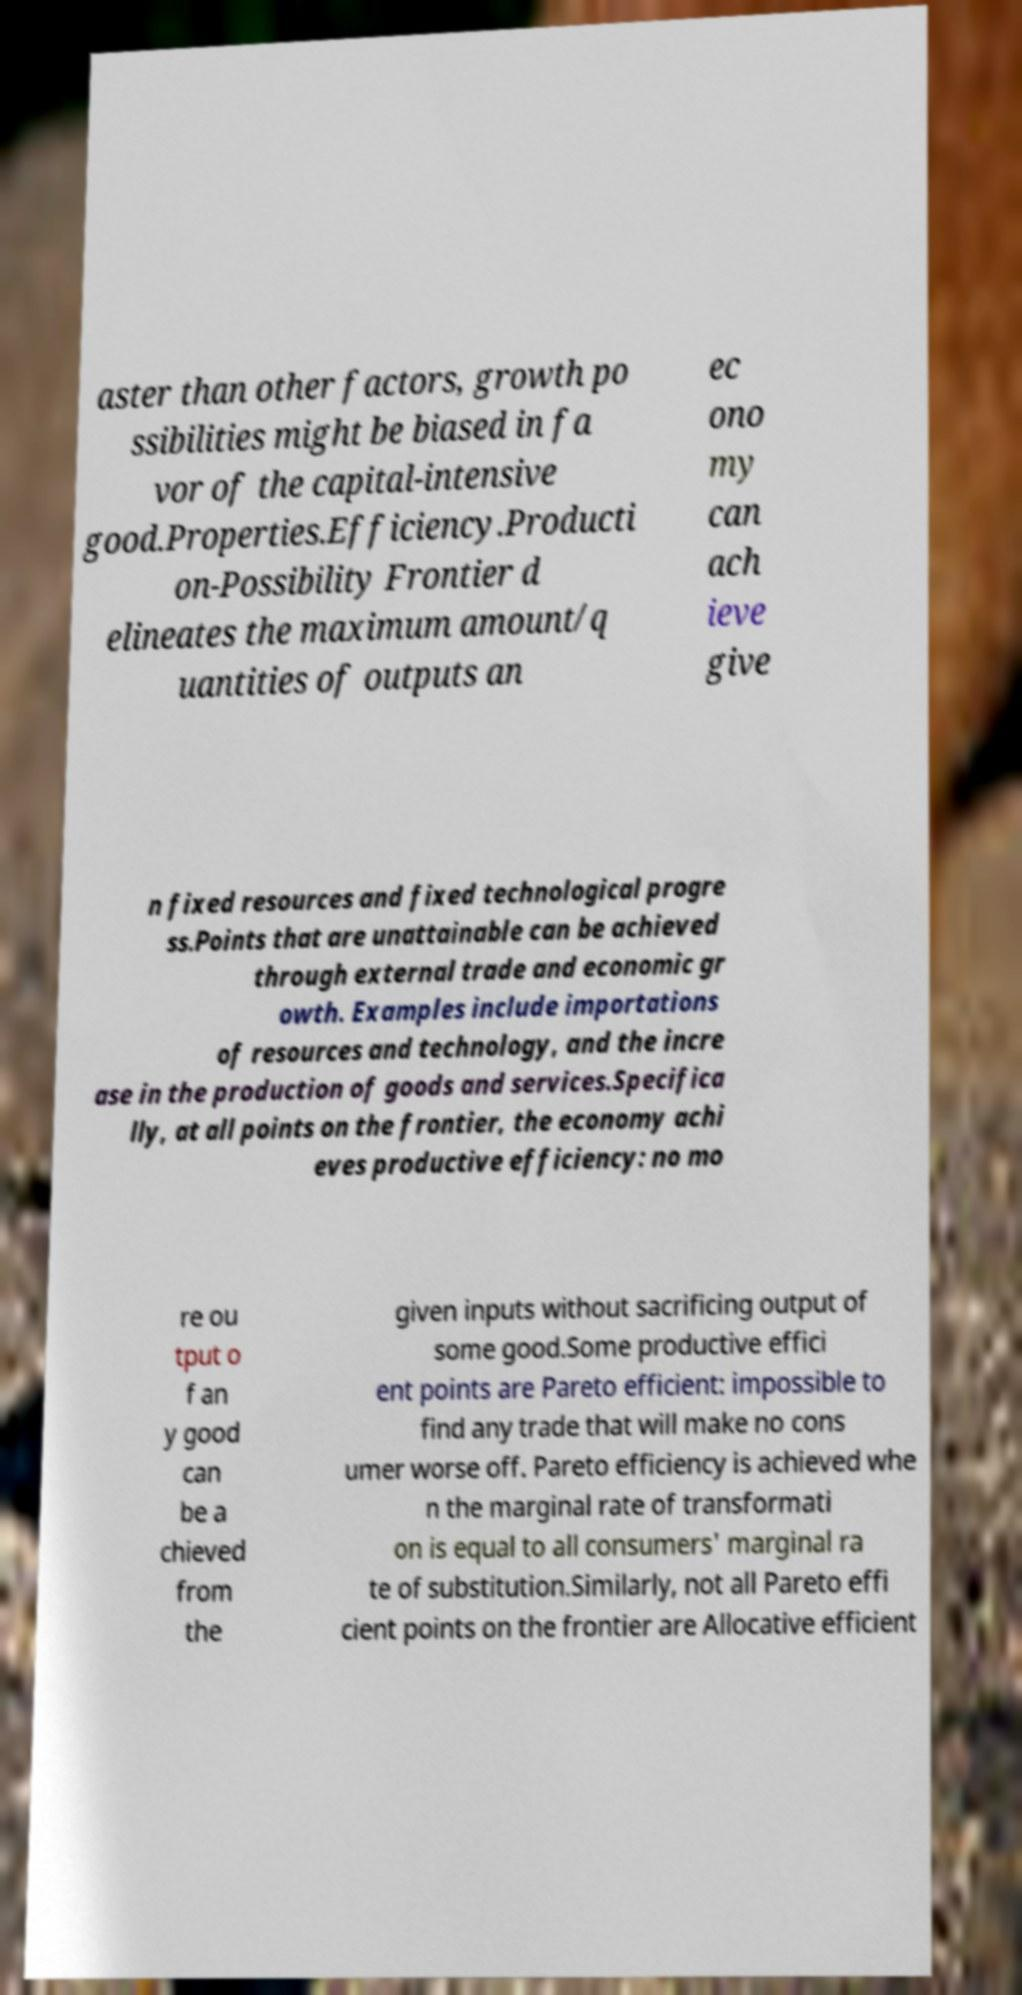I need the written content from this picture converted into text. Can you do that? aster than other factors, growth po ssibilities might be biased in fa vor of the capital-intensive good.Properties.Efficiency.Producti on-Possibility Frontier d elineates the maximum amount/q uantities of outputs an ec ono my can ach ieve give n fixed resources and fixed technological progre ss.Points that are unattainable can be achieved through external trade and economic gr owth. Examples include importations of resources and technology, and the incre ase in the production of goods and services.Specifica lly, at all points on the frontier, the economy achi eves productive efficiency: no mo re ou tput o f an y good can be a chieved from the given inputs without sacrificing output of some good.Some productive effici ent points are Pareto efficient: impossible to find any trade that will make no cons umer worse off. Pareto efficiency is achieved whe n the marginal rate of transformati on is equal to all consumers' marginal ra te of substitution.Similarly, not all Pareto effi cient points on the frontier are Allocative efficient 